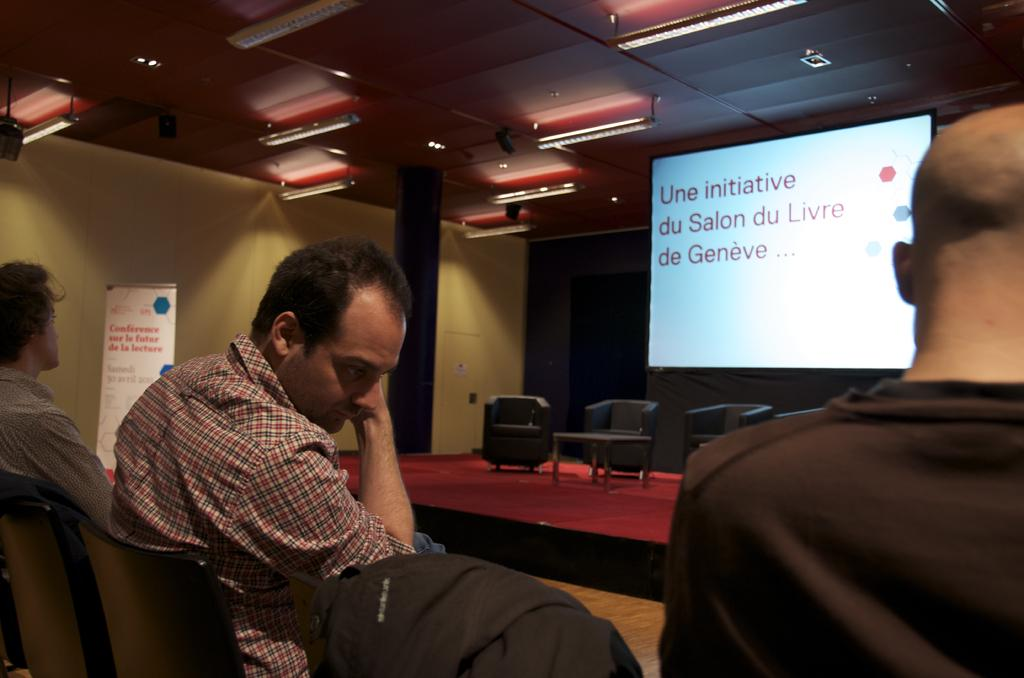What are the people in the image doing? The persons in the image are sitting on chairs. What can be seen in the background of the image? In the background of the image, there is a dais, chairs, tables, a screen, a pillar, a wall, and lights. Can you describe the setting of the image? The image appears to be set in a room with a dais, chairs, tables, a screen, a pillar, a wall, and lights, where people are sitting on chairs. How many bikes are parked near the pillar in the image? There are no bikes present in the image. What type of muscle is being exercised by the persons sitting on chairs in the image? The persons sitting on chairs in the image are not exercising any muscles, as they are simply sitting. 